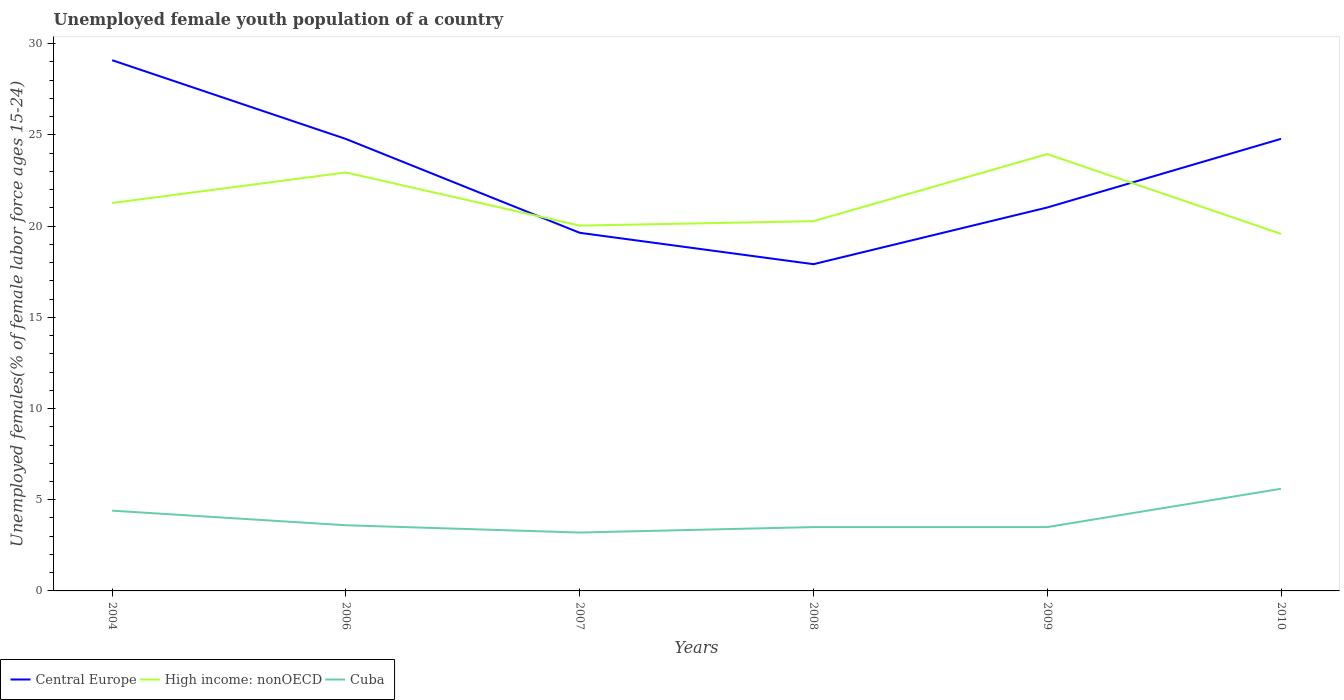How many different coloured lines are there?
Give a very brief answer. 3. Is the number of lines equal to the number of legend labels?
Your response must be concise. Yes. Across all years, what is the maximum percentage of unemployed female youth population in Cuba?
Provide a short and direct response. 3.2. What is the total percentage of unemployed female youth population in Cuba in the graph?
Offer a terse response. 0.8. What is the difference between the highest and the second highest percentage of unemployed female youth population in High income: nonOECD?
Provide a short and direct response. 4.37. What is the difference between two consecutive major ticks on the Y-axis?
Provide a succinct answer. 5. Are the values on the major ticks of Y-axis written in scientific E-notation?
Keep it short and to the point. No. Does the graph contain any zero values?
Your answer should be compact. No. Where does the legend appear in the graph?
Offer a very short reply. Bottom left. How many legend labels are there?
Offer a terse response. 3. What is the title of the graph?
Ensure brevity in your answer.  Unemployed female youth population of a country. Does "Armenia" appear as one of the legend labels in the graph?
Your answer should be compact. No. What is the label or title of the Y-axis?
Offer a very short reply. Unemployed females(% of female labor force ages 15-24). What is the Unemployed females(% of female labor force ages 15-24) in Central Europe in 2004?
Offer a very short reply. 29.1. What is the Unemployed females(% of female labor force ages 15-24) in High income: nonOECD in 2004?
Offer a very short reply. 21.27. What is the Unemployed females(% of female labor force ages 15-24) of Cuba in 2004?
Give a very brief answer. 4.4. What is the Unemployed females(% of female labor force ages 15-24) in Central Europe in 2006?
Ensure brevity in your answer.  24.78. What is the Unemployed females(% of female labor force ages 15-24) of High income: nonOECD in 2006?
Your response must be concise. 22.94. What is the Unemployed females(% of female labor force ages 15-24) in Cuba in 2006?
Ensure brevity in your answer.  3.6. What is the Unemployed females(% of female labor force ages 15-24) of Central Europe in 2007?
Keep it short and to the point. 19.63. What is the Unemployed females(% of female labor force ages 15-24) of High income: nonOECD in 2007?
Offer a terse response. 20.03. What is the Unemployed females(% of female labor force ages 15-24) of Cuba in 2007?
Give a very brief answer. 3.2. What is the Unemployed females(% of female labor force ages 15-24) in Central Europe in 2008?
Offer a terse response. 17.91. What is the Unemployed females(% of female labor force ages 15-24) in High income: nonOECD in 2008?
Your answer should be compact. 20.27. What is the Unemployed females(% of female labor force ages 15-24) of Central Europe in 2009?
Keep it short and to the point. 21.02. What is the Unemployed females(% of female labor force ages 15-24) of High income: nonOECD in 2009?
Provide a succinct answer. 23.95. What is the Unemployed females(% of female labor force ages 15-24) of Central Europe in 2010?
Provide a short and direct response. 24.79. What is the Unemployed females(% of female labor force ages 15-24) of High income: nonOECD in 2010?
Keep it short and to the point. 19.57. What is the Unemployed females(% of female labor force ages 15-24) in Cuba in 2010?
Offer a very short reply. 5.6. Across all years, what is the maximum Unemployed females(% of female labor force ages 15-24) of Central Europe?
Provide a short and direct response. 29.1. Across all years, what is the maximum Unemployed females(% of female labor force ages 15-24) of High income: nonOECD?
Ensure brevity in your answer.  23.95. Across all years, what is the maximum Unemployed females(% of female labor force ages 15-24) of Cuba?
Provide a succinct answer. 5.6. Across all years, what is the minimum Unemployed females(% of female labor force ages 15-24) in Central Europe?
Provide a succinct answer. 17.91. Across all years, what is the minimum Unemployed females(% of female labor force ages 15-24) of High income: nonOECD?
Offer a very short reply. 19.57. Across all years, what is the minimum Unemployed females(% of female labor force ages 15-24) of Cuba?
Make the answer very short. 3.2. What is the total Unemployed females(% of female labor force ages 15-24) of Central Europe in the graph?
Give a very brief answer. 137.23. What is the total Unemployed females(% of female labor force ages 15-24) in High income: nonOECD in the graph?
Make the answer very short. 128.03. What is the total Unemployed females(% of female labor force ages 15-24) of Cuba in the graph?
Your answer should be very brief. 23.8. What is the difference between the Unemployed females(% of female labor force ages 15-24) in Central Europe in 2004 and that in 2006?
Make the answer very short. 4.32. What is the difference between the Unemployed females(% of female labor force ages 15-24) in High income: nonOECD in 2004 and that in 2006?
Your answer should be very brief. -1.67. What is the difference between the Unemployed females(% of female labor force ages 15-24) of Cuba in 2004 and that in 2006?
Provide a short and direct response. 0.8. What is the difference between the Unemployed females(% of female labor force ages 15-24) in Central Europe in 2004 and that in 2007?
Ensure brevity in your answer.  9.46. What is the difference between the Unemployed females(% of female labor force ages 15-24) in High income: nonOECD in 2004 and that in 2007?
Your answer should be very brief. 1.24. What is the difference between the Unemployed females(% of female labor force ages 15-24) in Central Europe in 2004 and that in 2008?
Provide a short and direct response. 11.18. What is the difference between the Unemployed females(% of female labor force ages 15-24) of Central Europe in 2004 and that in 2009?
Your answer should be compact. 8.07. What is the difference between the Unemployed females(% of female labor force ages 15-24) of High income: nonOECD in 2004 and that in 2009?
Your answer should be compact. -2.68. What is the difference between the Unemployed females(% of female labor force ages 15-24) of Central Europe in 2004 and that in 2010?
Offer a terse response. 4.31. What is the difference between the Unemployed females(% of female labor force ages 15-24) of High income: nonOECD in 2004 and that in 2010?
Your response must be concise. 1.69. What is the difference between the Unemployed females(% of female labor force ages 15-24) of Cuba in 2004 and that in 2010?
Your response must be concise. -1.2. What is the difference between the Unemployed females(% of female labor force ages 15-24) in Central Europe in 2006 and that in 2007?
Give a very brief answer. 5.14. What is the difference between the Unemployed females(% of female labor force ages 15-24) in High income: nonOECD in 2006 and that in 2007?
Offer a very short reply. 2.91. What is the difference between the Unemployed females(% of female labor force ages 15-24) in Cuba in 2006 and that in 2007?
Your response must be concise. 0.4. What is the difference between the Unemployed females(% of female labor force ages 15-24) of Central Europe in 2006 and that in 2008?
Offer a terse response. 6.86. What is the difference between the Unemployed females(% of female labor force ages 15-24) in High income: nonOECD in 2006 and that in 2008?
Your answer should be very brief. 2.67. What is the difference between the Unemployed females(% of female labor force ages 15-24) in Cuba in 2006 and that in 2008?
Offer a very short reply. 0.1. What is the difference between the Unemployed females(% of female labor force ages 15-24) of Central Europe in 2006 and that in 2009?
Offer a terse response. 3.76. What is the difference between the Unemployed females(% of female labor force ages 15-24) in High income: nonOECD in 2006 and that in 2009?
Provide a succinct answer. -1.01. What is the difference between the Unemployed females(% of female labor force ages 15-24) in Cuba in 2006 and that in 2009?
Keep it short and to the point. 0.1. What is the difference between the Unemployed females(% of female labor force ages 15-24) of Central Europe in 2006 and that in 2010?
Your answer should be very brief. -0.01. What is the difference between the Unemployed females(% of female labor force ages 15-24) of High income: nonOECD in 2006 and that in 2010?
Your answer should be very brief. 3.37. What is the difference between the Unemployed females(% of female labor force ages 15-24) in Central Europe in 2007 and that in 2008?
Your response must be concise. 1.72. What is the difference between the Unemployed females(% of female labor force ages 15-24) of High income: nonOECD in 2007 and that in 2008?
Provide a short and direct response. -0.24. What is the difference between the Unemployed females(% of female labor force ages 15-24) in Central Europe in 2007 and that in 2009?
Provide a succinct answer. -1.39. What is the difference between the Unemployed females(% of female labor force ages 15-24) of High income: nonOECD in 2007 and that in 2009?
Ensure brevity in your answer.  -3.92. What is the difference between the Unemployed females(% of female labor force ages 15-24) in Cuba in 2007 and that in 2009?
Ensure brevity in your answer.  -0.3. What is the difference between the Unemployed females(% of female labor force ages 15-24) of Central Europe in 2007 and that in 2010?
Keep it short and to the point. -5.15. What is the difference between the Unemployed females(% of female labor force ages 15-24) in High income: nonOECD in 2007 and that in 2010?
Ensure brevity in your answer.  0.45. What is the difference between the Unemployed females(% of female labor force ages 15-24) of Central Europe in 2008 and that in 2009?
Your answer should be very brief. -3.11. What is the difference between the Unemployed females(% of female labor force ages 15-24) of High income: nonOECD in 2008 and that in 2009?
Offer a terse response. -3.68. What is the difference between the Unemployed females(% of female labor force ages 15-24) in Cuba in 2008 and that in 2009?
Provide a short and direct response. 0. What is the difference between the Unemployed females(% of female labor force ages 15-24) in Central Europe in 2008 and that in 2010?
Offer a terse response. -6.87. What is the difference between the Unemployed females(% of female labor force ages 15-24) of High income: nonOECD in 2008 and that in 2010?
Offer a very short reply. 0.7. What is the difference between the Unemployed females(% of female labor force ages 15-24) in Central Europe in 2009 and that in 2010?
Ensure brevity in your answer.  -3.76. What is the difference between the Unemployed females(% of female labor force ages 15-24) of High income: nonOECD in 2009 and that in 2010?
Give a very brief answer. 4.37. What is the difference between the Unemployed females(% of female labor force ages 15-24) in Cuba in 2009 and that in 2010?
Offer a very short reply. -2.1. What is the difference between the Unemployed females(% of female labor force ages 15-24) in Central Europe in 2004 and the Unemployed females(% of female labor force ages 15-24) in High income: nonOECD in 2006?
Offer a terse response. 6.16. What is the difference between the Unemployed females(% of female labor force ages 15-24) in Central Europe in 2004 and the Unemployed females(% of female labor force ages 15-24) in Cuba in 2006?
Ensure brevity in your answer.  25.5. What is the difference between the Unemployed females(% of female labor force ages 15-24) in High income: nonOECD in 2004 and the Unemployed females(% of female labor force ages 15-24) in Cuba in 2006?
Your response must be concise. 17.67. What is the difference between the Unemployed females(% of female labor force ages 15-24) in Central Europe in 2004 and the Unemployed females(% of female labor force ages 15-24) in High income: nonOECD in 2007?
Make the answer very short. 9.07. What is the difference between the Unemployed females(% of female labor force ages 15-24) of Central Europe in 2004 and the Unemployed females(% of female labor force ages 15-24) of Cuba in 2007?
Offer a very short reply. 25.9. What is the difference between the Unemployed females(% of female labor force ages 15-24) of High income: nonOECD in 2004 and the Unemployed females(% of female labor force ages 15-24) of Cuba in 2007?
Keep it short and to the point. 18.07. What is the difference between the Unemployed females(% of female labor force ages 15-24) of Central Europe in 2004 and the Unemployed females(% of female labor force ages 15-24) of High income: nonOECD in 2008?
Your answer should be compact. 8.83. What is the difference between the Unemployed females(% of female labor force ages 15-24) of Central Europe in 2004 and the Unemployed females(% of female labor force ages 15-24) of Cuba in 2008?
Offer a very short reply. 25.6. What is the difference between the Unemployed females(% of female labor force ages 15-24) in High income: nonOECD in 2004 and the Unemployed females(% of female labor force ages 15-24) in Cuba in 2008?
Provide a succinct answer. 17.77. What is the difference between the Unemployed females(% of female labor force ages 15-24) in Central Europe in 2004 and the Unemployed females(% of female labor force ages 15-24) in High income: nonOECD in 2009?
Offer a very short reply. 5.15. What is the difference between the Unemployed females(% of female labor force ages 15-24) of Central Europe in 2004 and the Unemployed females(% of female labor force ages 15-24) of Cuba in 2009?
Offer a terse response. 25.6. What is the difference between the Unemployed females(% of female labor force ages 15-24) of High income: nonOECD in 2004 and the Unemployed females(% of female labor force ages 15-24) of Cuba in 2009?
Give a very brief answer. 17.77. What is the difference between the Unemployed females(% of female labor force ages 15-24) in Central Europe in 2004 and the Unemployed females(% of female labor force ages 15-24) in High income: nonOECD in 2010?
Your answer should be very brief. 9.52. What is the difference between the Unemployed females(% of female labor force ages 15-24) in Central Europe in 2004 and the Unemployed females(% of female labor force ages 15-24) in Cuba in 2010?
Give a very brief answer. 23.5. What is the difference between the Unemployed females(% of female labor force ages 15-24) of High income: nonOECD in 2004 and the Unemployed females(% of female labor force ages 15-24) of Cuba in 2010?
Offer a terse response. 15.67. What is the difference between the Unemployed females(% of female labor force ages 15-24) of Central Europe in 2006 and the Unemployed females(% of female labor force ages 15-24) of High income: nonOECD in 2007?
Keep it short and to the point. 4.75. What is the difference between the Unemployed females(% of female labor force ages 15-24) in Central Europe in 2006 and the Unemployed females(% of female labor force ages 15-24) in Cuba in 2007?
Your answer should be very brief. 21.58. What is the difference between the Unemployed females(% of female labor force ages 15-24) in High income: nonOECD in 2006 and the Unemployed females(% of female labor force ages 15-24) in Cuba in 2007?
Provide a succinct answer. 19.74. What is the difference between the Unemployed females(% of female labor force ages 15-24) of Central Europe in 2006 and the Unemployed females(% of female labor force ages 15-24) of High income: nonOECD in 2008?
Provide a succinct answer. 4.51. What is the difference between the Unemployed females(% of female labor force ages 15-24) of Central Europe in 2006 and the Unemployed females(% of female labor force ages 15-24) of Cuba in 2008?
Ensure brevity in your answer.  21.28. What is the difference between the Unemployed females(% of female labor force ages 15-24) in High income: nonOECD in 2006 and the Unemployed females(% of female labor force ages 15-24) in Cuba in 2008?
Provide a short and direct response. 19.44. What is the difference between the Unemployed females(% of female labor force ages 15-24) in Central Europe in 2006 and the Unemployed females(% of female labor force ages 15-24) in High income: nonOECD in 2009?
Provide a succinct answer. 0.83. What is the difference between the Unemployed females(% of female labor force ages 15-24) of Central Europe in 2006 and the Unemployed females(% of female labor force ages 15-24) of Cuba in 2009?
Your answer should be very brief. 21.28. What is the difference between the Unemployed females(% of female labor force ages 15-24) in High income: nonOECD in 2006 and the Unemployed females(% of female labor force ages 15-24) in Cuba in 2009?
Provide a short and direct response. 19.44. What is the difference between the Unemployed females(% of female labor force ages 15-24) of Central Europe in 2006 and the Unemployed females(% of female labor force ages 15-24) of High income: nonOECD in 2010?
Ensure brevity in your answer.  5.2. What is the difference between the Unemployed females(% of female labor force ages 15-24) in Central Europe in 2006 and the Unemployed females(% of female labor force ages 15-24) in Cuba in 2010?
Provide a short and direct response. 19.18. What is the difference between the Unemployed females(% of female labor force ages 15-24) in High income: nonOECD in 2006 and the Unemployed females(% of female labor force ages 15-24) in Cuba in 2010?
Offer a very short reply. 17.34. What is the difference between the Unemployed females(% of female labor force ages 15-24) in Central Europe in 2007 and the Unemployed females(% of female labor force ages 15-24) in High income: nonOECD in 2008?
Make the answer very short. -0.64. What is the difference between the Unemployed females(% of female labor force ages 15-24) in Central Europe in 2007 and the Unemployed females(% of female labor force ages 15-24) in Cuba in 2008?
Offer a very short reply. 16.13. What is the difference between the Unemployed females(% of female labor force ages 15-24) in High income: nonOECD in 2007 and the Unemployed females(% of female labor force ages 15-24) in Cuba in 2008?
Your answer should be compact. 16.53. What is the difference between the Unemployed females(% of female labor force ages 15-24) of Central Europe in 2007 and the Unemployed females(% of female labor force ages 15-24) of High income: nonOECD in 2009?
Offer a terse response. -4.32. What is the difference between the Unemployed females(% of female labor force ages 15-24) in Central Europe in 2007 and the Unemployed females(% of female labor force ages 15-24) in Cuba in 2009?
Offer a terse response. 16.13. What is the difference between the Unemployed females(% of female labor force ages 15-24) in High income: nonOECD in 2007 and the Unemployed females(% of female labor force ages 15-24) in Cuba in 2009?
Provide a short and direct response. 16.53. What is the difference between the Unemployed females(% of female labor force ages 15-24) in Central Europe in 2007 and the Unemployed females(% of female labor force ages 15-24) in High income: nonOECD in 2010?
Provide a succinct answer. 0.06. What is the difference between the Unemployed females(% of female labor force ages 15-24) of Central Europe in 2007 and the Unemployed females(% of female labor force ages 15-24) of Cuba in 2010?
Your answer should be compact. 14.03. What is the difference between the Unemployed females(% of female labor force ages 15-24) in High income: nonOECD in 2007 and the Unemployed females(% of female labor force ages 15-24) in Cuba in 2010?
Ensure brevity in your answer.  14.43. What is the difference between the Unemployed females(% of female labor force ages 15-24) in Central Europe in 2008 and the Unemployed females(% of female labor force ages 15-24) in High income: nonOECD in 2009?
Provide a succinct answer. -6.04. What is the difference between the Unemployed females(% of female labor force ages 15-24) of Central Europe in 2008 and the Unemployed females(% of female labor force ages 15-24) of Cuba in 2009?
Your answer should be very brief. 14.41. What is the difference between the Unemployed females(% of female labor force ages 15-24) of High income: nonOECD in 2008 and the Unemployed females(% of female labor force ages 15-24) of Cuba in 2009?
Your answer should be very brief. 16.77. What is the difference between the Unemployed females(% of female labor force ages 15-24) of Central Europe in 2008 and the Unemployed females(% of female labor force ages 15-24) of High income: nonOECD in 2010?
Your answer should be very brief. -1.66. What is the difference between the Unemployed females(% of female labor force ages 15-24) in Central Europe in 2008 and the Unemployed females(% of female labor force ages 15-24) in Cuba in 2010?
Provide a short and direct response. 12.31. What is the difference between the Unemployed females(% of female labor force ages 15-24) of High income: nonOECD in 2008 and the Unemployed females(% of female labor force ages 15-24) of Cuba in 2010?
Provide a succinct answer. 14.67. What is the difference between the Unemployed females(% of female labor force ages 15-24) in Central Europe in 2009 and the Unemployed females(% of female labor force ages 15-24) in High income: nonOECD in 2010?
Your response must be concise. 1.45. What is the difference between the Unemployed females(% of female labor force ages 15-24) in Central Europe in 2009 and the Unemployed females(% of female labor force ages 15-24) in Cuba in 2010?
Your answer should be compact. 15.42. What is the difference between the Unemployed females(% of female labor force ages 15-24) of High income: nonOECD in 2009 and the Unemployed females(% of female labor force ages 15-24) of Cuba in 2010?
Provide a succinct answer. 18.35. What is the average Unemployed females(% of female labor force ages 15-24) in Central Europe per year?
Your answer should be compact. 22.87. What is the average Unemployed females(% of female labor force ages 15-24) of High income: nonOECD per year?
Offer a terse response. 21.34. What is the average Unemployed females(% of female labor force ages 15-24) of Cuba per year?
Provide a succinct answer. 3.97. In the year 2004, what is the difference between the Unemployed females(% of female labor force ages 15-24) of Central Europe and Unemployed females(% of female labor force ages 15-24) of High income: nonOECD?
Your response must be concise. 7.83. In the year 2004, what is the difference between the Unemployed females(% of female labor force ages 15-24) of Central Europe and Unemployed females(% of female labor force ages 15-24) of Cuba?
Provide a short and direct response. 24.7. In the year 2004, what is the difference between the Unemployed females(% of female labor force ages 15-24) in High income: nonOECD and Unemployed females(% of female labor force ages 15-24) in Cuba?
Your response must be concise. 16.87. In the year 2006, what is the difference between the Unemployed females(% of female labor force ages 15-24) in Central Europe and Unemployed females(% of female labor force ages 15-24) in High income: nonOECD?
Your answer should be very brief. 1.84. In the year 2006, what is the difference between the Unemployed females(% of female labor force ages 15-24) of Central Europe and Unemployed females(% of female labor force ages 15-24) of Cuba?
Keep it short and to the point. 21.18. In the year 2006, what is the difference between the Unemployed females(% of female labor force ages 15-24) in High income: nonOECD and Unemployed females(% of female labor force ages 15-24) in Cuba?
Offer a very short reply. 19.34. In the year 2007, what is the difference between the Unemployed females(% of female labor force ages 15-24) of Central Europe and Unemployed females(% of female labor force ages 15-24) of High income: nonOECD?
Your answer should be compact. -0.39. In the year 2007, what is the difference between the Unemployed females(% of female labor force ages 15-24) of Central Europe and Unemployed females(% of female labor force ages 15-24) of Cuba?
Provide a short and direct response. 16.43. In the year 2007, what is the difference between the Unemployed females(% of female labor force ages 15-24) in High income: nonOECD and Unemployed females(% of female labor force ages 15-24) in Cuba?
Give a very brief answer. 16.83. In the year 2008, what is the difference between the Unemployed females(% of female labor force ages 15-24) of Central Europe and Unemployed females(% of female labor force ages 15-24) of High income: nonOECD?
Your response must be concise. -2.36. In the year 2008, what is the difference between the Unemployed females(% of female labor force ages 15-24) of Central Europe and Unemployed females(% of female labor force ages 15-24) of Cuba?
Offer a very short reply. 14.41. In the year 2008, what is the difference between the Unemployed females(% of female labor force ages 15-24) in High income: nonOECD and Unemployed females(% of female labor force ages 15-24) in Cuba?
Ensure brevity in your answer.  16.77. In the year 2009, what is the difference between the Unemployed females(% of female labor force ages 15-24) in Central Europe and Unemployed females(% of female labor force ages 15-24) in High income: nonOECD?
Your answer should be compact. -2.93. In the year 2009, what is the difference between the Unemployed females(% of female labor force ages 15-24) of Central Europe and Unemployed females(% of female labor force ages 15-24) of Cuba?
Your answer should be compact. 17.52. In the year 2009, what is the difference between the Unemployed females(% of female labor force ages 15-24) of High income: nonOECD and Unemployed females(% of female labor force ages 15-24) of Cuba?
Your answer should be very brief. 20.45. In the year 2010, what is the difference between the Unemployed females(% of female labor force ages 15-24) in Central Europe and Unemployed females(% of female labor force ages 15-24) in High income: nonOECD?
Ensure brevity in your answer.  5.21. In the year 2010, what is the difference between the Unemployed females(% of female labor force ages 15-24) of Central Europe and Unemployed females(% of female labor force ages 15-24) of Cuba?
Your response must be concise. 19.19. In the year 2010, what is the difference between the Unemployed females(% of female labor force ages 15-24) of High income: nonOECD and Unemployed females(% of female labor force ages 15-24) of Cuba?
Keep it short and to the point. 13.97. What is the ratio of the Unemployed females(% of female labor force ages 15-24) in Central Europe in 2004 to that in 2006?
Provide a succinct answer. 1.17. What is the ratio of the Unemployed females(% of female labor force ages 15-24) in High income: nonOECD in 2004 to that in 2006?
Give a very brief answer. 0.93. What is the ratio of the Unemployed females(% of female labor force ages 15-24) in Cuba in 2004 to that in 2006?
Your answer should be compact. 1.22. What is the ratio of the Unemployed females(% of female labor force ages 15-24) of Central Europe in 2004 to that in 2007?
Make the answer very short. 1.48. What is the ratio of the Unemployed females(% of female labor force ages 15-24) in High income: nonOECD in 2004 to that in 2007?
Offer a very short reply. 1.06. What is the ratio of the Unemployed females(% of female labor force ages 15-24) in Cuba in 2004 to that in 2007?
Your response must be concise. 1.38. What is the ratio of the Unemployed females(% of female labor force ages 15-24) in Central Europe in 2004 to that in 2008?
Give a very brief answer. 1.62. What is the ratio of the Unemployed females(% of female labor force ages 15-24) in High income: nonOECD in 2004 to that in 2008?
Your answer should be very brief. 1.05. What is the ratio of the Unemployed females(% of female labor force ages 15-24) of Cuba in 2004 to that in 2008?
Offer a very short reply. 1.26. What is the ratio of the Unemployed females(% of female labor force ages 15-24) in Central Europe in 2004 to that in 2009?
Your response must be concise. 1.38. What is the ratio of the Unemployed females(% of female labor force ages 15-24) in High income: nonOECD in 2004 to that in 2009?
Your response must be concise. 0.89. What is the ratio of the Unemployed females(% of female labor force ages 15-24) of Cuba in 2004 to that in 2009?
Keep it short and to the point. 1.26. What is the ratio of the Unemployed females(% of female labor force ages 15-24) in Central Europe in 2004 to that in 2010?
Your answer should be very brief. 1.17. What is the ratio of the Unemployed females(% of female labor force ages 15-24) in High income: nonOECD in 2004 to that in 2010?
Your answer should be compact. 1.09. What is the ratio of the Unemployed females(% of female labor force ages 15-24) of Cuba in 2004 to that in 2010?
Offer a very short reply. 0.79. What is the ratio of the Unemployed females(% of female labor force ages 15-24) of Central Europe in 2006 to that in 2007?
Keep it short and to the point. 1.26. What is the ratio of the Unemployed females(% of female labor force ages 15-24) of High income: nonOECD in 2006 to that in 2007?
Your response must be concise. 1.15. What is the ratio of the Unemployed females(% of female labor force ages 15-24) of Central Europe in 2006 to that in 2008?
Your response must be concise. 1.38. What is the ratio of the Unemployed females(% of female labor force ages 15-24) of High income: nonOECD in 2006 to that in 2008?
Your answer should be compact. 1.13. What is the ratio of the Unemployed females(% of female labor force ages 15-24) in Cuba in 2006 to that in 2008?
Your answer should be compact. 1.03. What is the ratio of the Unemployed females(% of female labor force ages 15-24) in Central Europe in 2006 to that in 2009?
Offer a terse response. 1.18. What is the ratio of the Unemployed females(% of female labor force ages 15-24) of High income: nonOECD in 2006 to that in 2009?
Your response must be concise. 0.96. What is the ratio of the Unemployed females(% of female labor force ages 15-24) in Cuba in 2006 to that in 2009?
Ensure brevity in your answer.  1.03. What is the ratio of the Unemployed females(% of female labor force ages 15-24) in High income: nonOECD in 2006 to that in 2010?
Your answer should be compact. 1.17. What is the ratio of the Unemployed females(% of female labor force ages 15-24) in Cuba in 2006 to that in 2010?
Keep it short and to the point. 0.64. What is the ratio of the Unemployed females(% of female labor force ages 15-24) in Central Europe in 2007 to that in 2008?
Provide a succinct answer. 1.1. What is the ratio of the Unemployed females(% of female labor force ages 15-24) in Cuba in 2007 to that in 2008?
Your answer should be compact. 0.91. What is the ratio of the Unemployed females(% of female labor force ages 15-24) of Central Europe in 2007 to that in 2009?
Ensure brevity in your answer.  0.93. What is the ratio of the Unemployed females(% of female labor force ages 15-24) of High income: nonOECD in 2007 to that in 2009?
Offer a very short reply. 0.84. What is the ratio of the Unemployed females(% of female labor force ages 15-24) in Cuba in 2007 to that in 2009?
Provide a succinct answer. 0.91. What is the ratio of the Unemployed females(% of female labor force ages 15-24) in Central Europe in 2007 to that in 2010?
Make the answer very short. 0.79. What is the ratio of the Unemployed females(% of female labor force ages 15-24) of High income: nonOECD in 2007 to that in 2010?
Provide a succinct answer. 1.02. What is the ratio of the Unemployed females(% of female labor force ages 15-24) in Central Europe in 2008 to that in 2009?
Your answer should be compact. 0.85. What is the ratio of the Unemployed females(% of female labor force ages 15-24) in High income: nonOECD in 2008 to that in 2009?
Provide a succinct answer. 0.85. What is the ratio of the Unemployed females(% of female labor force ages 15-24) in Cuba in 2008 to that in 2009?
Offer a very short reply. 1. What is the ratio of the Unemployed females(% of female labor force ages 15-24) of Central Europe in 2008 to that in 2010?
Ensure brevity in your answer.  0.72. What is the ratio of the Unemployed females(% of female labor force ages 15-24) in High income: nonOECD in 2008 to that in 2010?
Your answer should be very brief. 1.04. What is the ratio of the Unemployed females(% of female labor force ages 15-24) in Cuba in 2008 to that in 2010?
Provide a short and direct response. 0.62. What is the ratio of the Unemployed females(% of female labor force ages 15-24) in Central Europe in 2009 to that in 2010?
Ensure brevity in your answer.  0.85. What is the ratio of the Unemployed females(% of female labor force ages 15-24) in High income: nonOECD in 2009 to that in 2010?
Offer a terse response. 1.22. What is the difference between the highest and the second highest Unemployed females(% of female labor force ages 15-24) in Central Europe?
Ensure brevity in your answer.  4.31. What is the difference between the highest and the second highest Unemployed females(% of female labor force ages 15-24) of Cuba?
Your response must be concise. 1.2. What is the difference between the highest and the lowest Unemployed females(% of female labor force ages 15-24) of Central Europe?
Ensure brevity in your answer.  11.18. What is the difference between the highest and the lowest Unemployed females(% of female labor force ages 15-24) of High income: nonOECD?
Offer a terse response. 4.37. What is the difference between the highest and the lowest Unemployed females(% of female labor force ages 15-24) in Cuba?
Give a very brief answer. 2.4. 